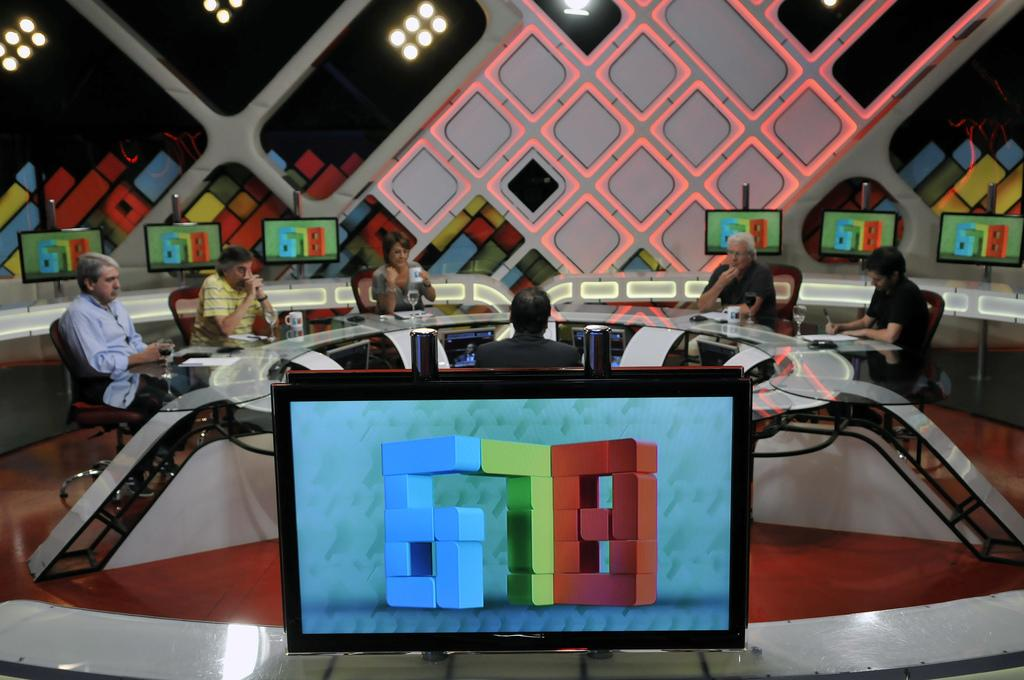<image>
Present a compact description of the photo's key features. A computer monitor with the logo for 678 with an interview going on in the background. 